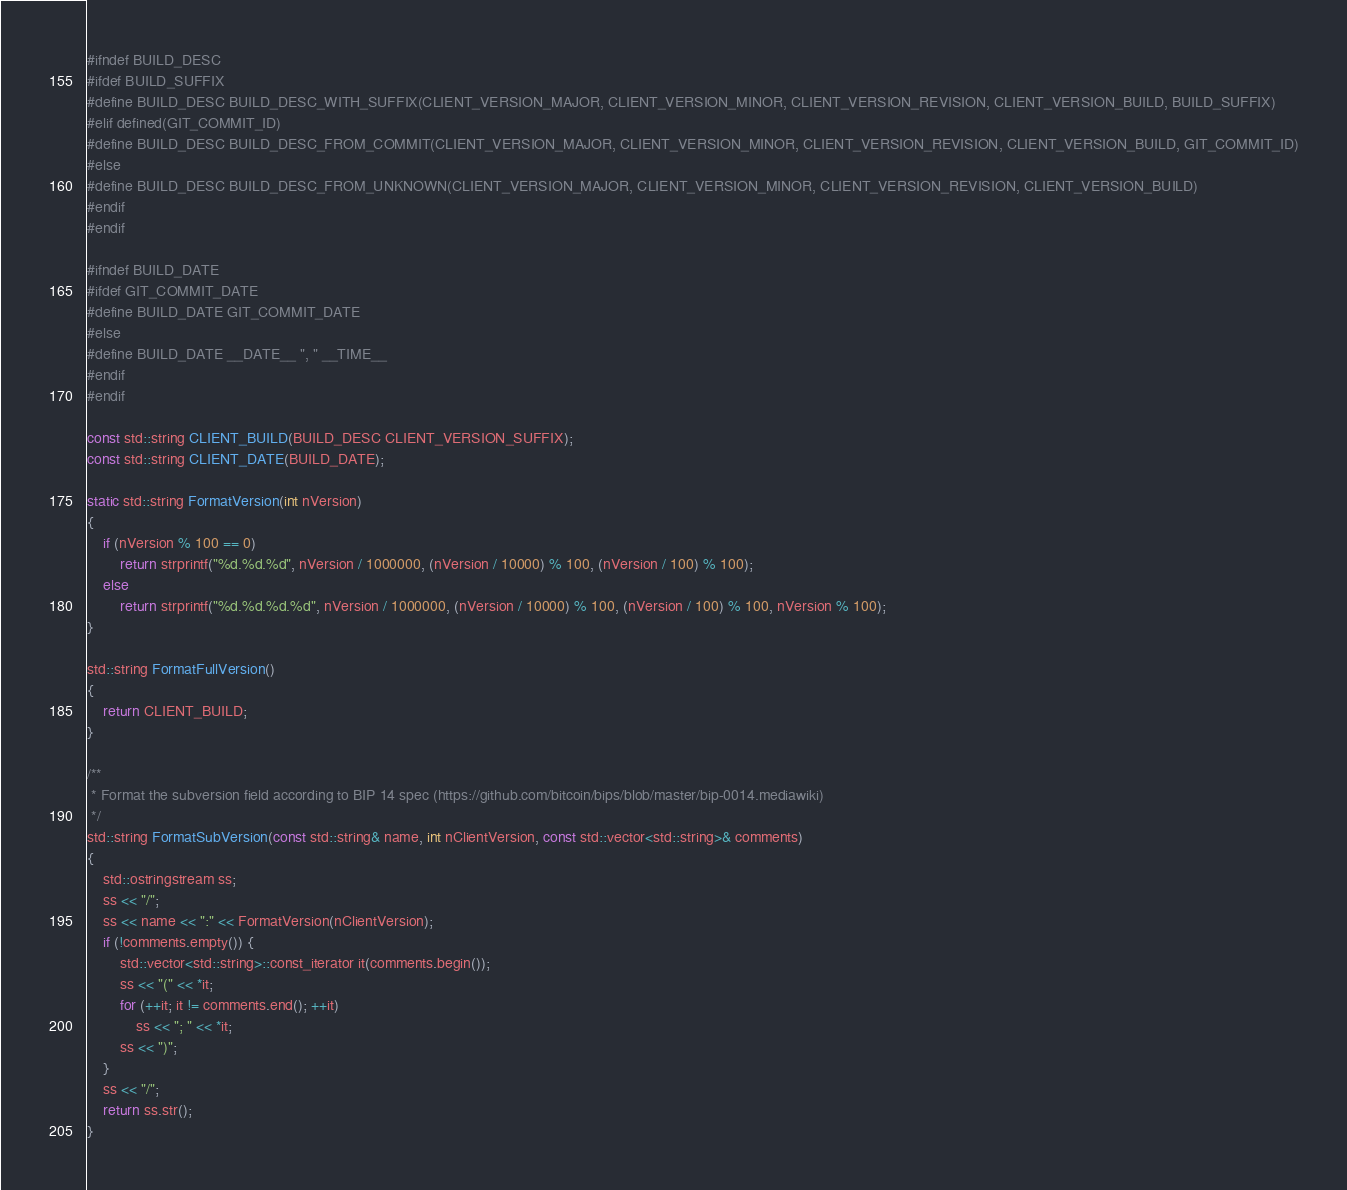Convert code to text. <code><loc_0><loc_0><loc_500><loc_500><_C++_>
#ifndef BUILD_DESC
#ifdef BUILD_SUFFIX
#define BUILD_DESC BUILD_DESC_WITH_SUFFIX(CLIENT_VERSION_MAJOR, CLIENT_VERSION_MINOR, CLIENT_VERSION_REVISION, CLIENT_VERSION_BUILD, BUILD_SUFFIX)
#elif defined(GIT_COMMIT_ID)
#define BUILD_DESC BUILD_DESC_FROM_COMMIT(CLIENT_VERSION_MAJOR, CLIENT_VERSION_MINOR, CLIENT_VERSION_REVISION, CLIENT_VERSION_BUILD, GIT_COMMIT_ID)
#else
#define BUILD_DESC BUILD_DESC_FROM_UNKNOWN(CLIENT_VERSION_MAJOR, CLIENT_VERSION_MINOR, CLIENT_VERSION_REVISION, CLIENT_VERSION_BUILD)
#endif
#endif

#ifndef BUILD_DATE
#ifdef GIT_COMMIT_DATE
#define BUILD_DATE GIT_COMMIT_DATE
#else
#define BUILD_DATE __DATE__ ", " __TIME__
#endif
#endif

const std::string CLIENT_BUILD(BUILD_DESC CLIENT_VERSION_SUFFIX);
const std::string CLIENT_DATE(BUILD_DATE);

static std::string FormatVersion(int nVersion)
{
    if (nVersion % 100 == 0)
        return strprintf("%d.%d.%d", nVersion / 1000000, (nVersion / 10000) % 100, (nVersion / 100) % 100);
    else
        return strprintf("%d.%d.%d.%d", nVersion / 1000000, (nVersion / 10000) % 100, (nVersion / 100) % 100, nVersion % 100);
}

std::string FormatFullVersion()
{
    return CLIENT_BUILD;
}

/** 
 * Format the subversion field according to BIP 14 spec (https://github.com/bitcoin/bips/blob/master/bip-0014.mediawiki) 
 */
std::string FormatSubVersion(const std::string& name, int nClientVersion, const std::vector<std::string>& comments)
{
    std::ostringstream ss;
    ss << "/";
    ss << name << ":" << FormatVersion(nClientVersion);
    if (!comments.empty()) {
        std::vector<std::string>::const_iterator it(comments.begin());
        ss << "(" << *it;
        for (++it; it != comments.end(); ++it)
            ss << "; " << *it;
        ss << ")";
    }
    ss << "/";
    return ss.str();
}
</code> 